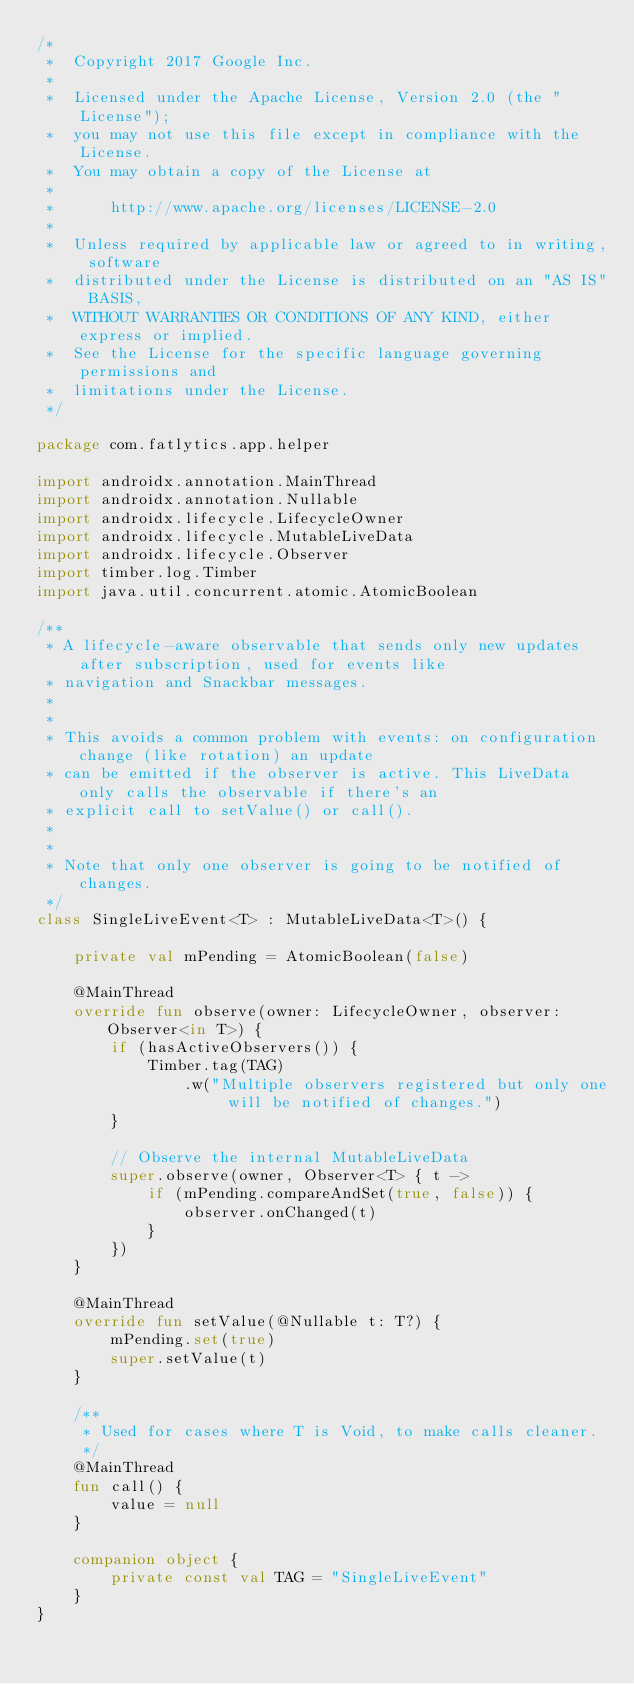<code> <loc_0><loc_0><loc_500><loc_500><_Kotlin_>/*
 *  Copyright 2017 Google Inc.
 *
 *  Licensed under the Apache License, Version 2.0 (the "License");
 *  you may not use this file except in compliance with the License.
 *  You may obtain a copy of the License at
 *
 *      http://www.apache.org/licenses/LICENSE-2.0
 *
 *  Unless required by applicable law or agreed to in writing, software
 *  distributed under the License is distributed on an "AS IS" BASIS,
 *  WITHOUT WARRANTIES OR CONDITIONS OF ANY KIND, either express or implied.
 *  See the License for the specific language governing permissions and
 *  limitations under the License.
 */

package com.fatlytics.app.helper

import androidx.annotation.MainThread
import androidx.annotation.Nullable
import androidx.lifecycle.LifecycleOwner
import androidx.lifecycle.MutableLiveData
import androidx.lifecycle.Observer
import timber.log.Timber
import java.util.concurrent.atomic.AtomicBoolean

/**
 * A lifecycle-aware observable that sends only new updates after subscription, used for events like
 * navigation and Snackbar messages.
 *
 *
 * This avoids a common problem with events: on configuration change (like rotation) an update
 * can be emitted if the observer is active. This LiveData only calls the observable if there's an
 * explicit call to setValue() or call().
 *
 *
 * Note that only one observer is going to be notified of changes.
 */
class SingleLiveEvent<T> : MutableLiveData<T>() {

    private val mPending = AtomicBoolean(false)

    @MainThread
    override fun observe(owner: LifecycleOwner, observer: Observer<in T>) {
        if (hasActiveObservers()) {
            Timber.tag(TAG)
                .w("Multiple observers registered but only one will be notified of changes.")
        }

        // Observe the internal MutableLiveData
        super.observe(owner, Observer<T> { t ->
            if (mPending.compareAndSet(true, false)) {
                observer.onChanged(t)
            }
        })
    }

    @MainThread
    override fun setValue(@Nullable t: T?) {
        mPending.set(true)
        super.setValue(t)
    }

    /**
     * Used for cases where T is Void, to make calls cleaner.
     */
    @MainThread
    fun call() {
        value = null
    }

    companion object {
        private const val TAG = "SingleLiveEvent"
    }
}</code> 